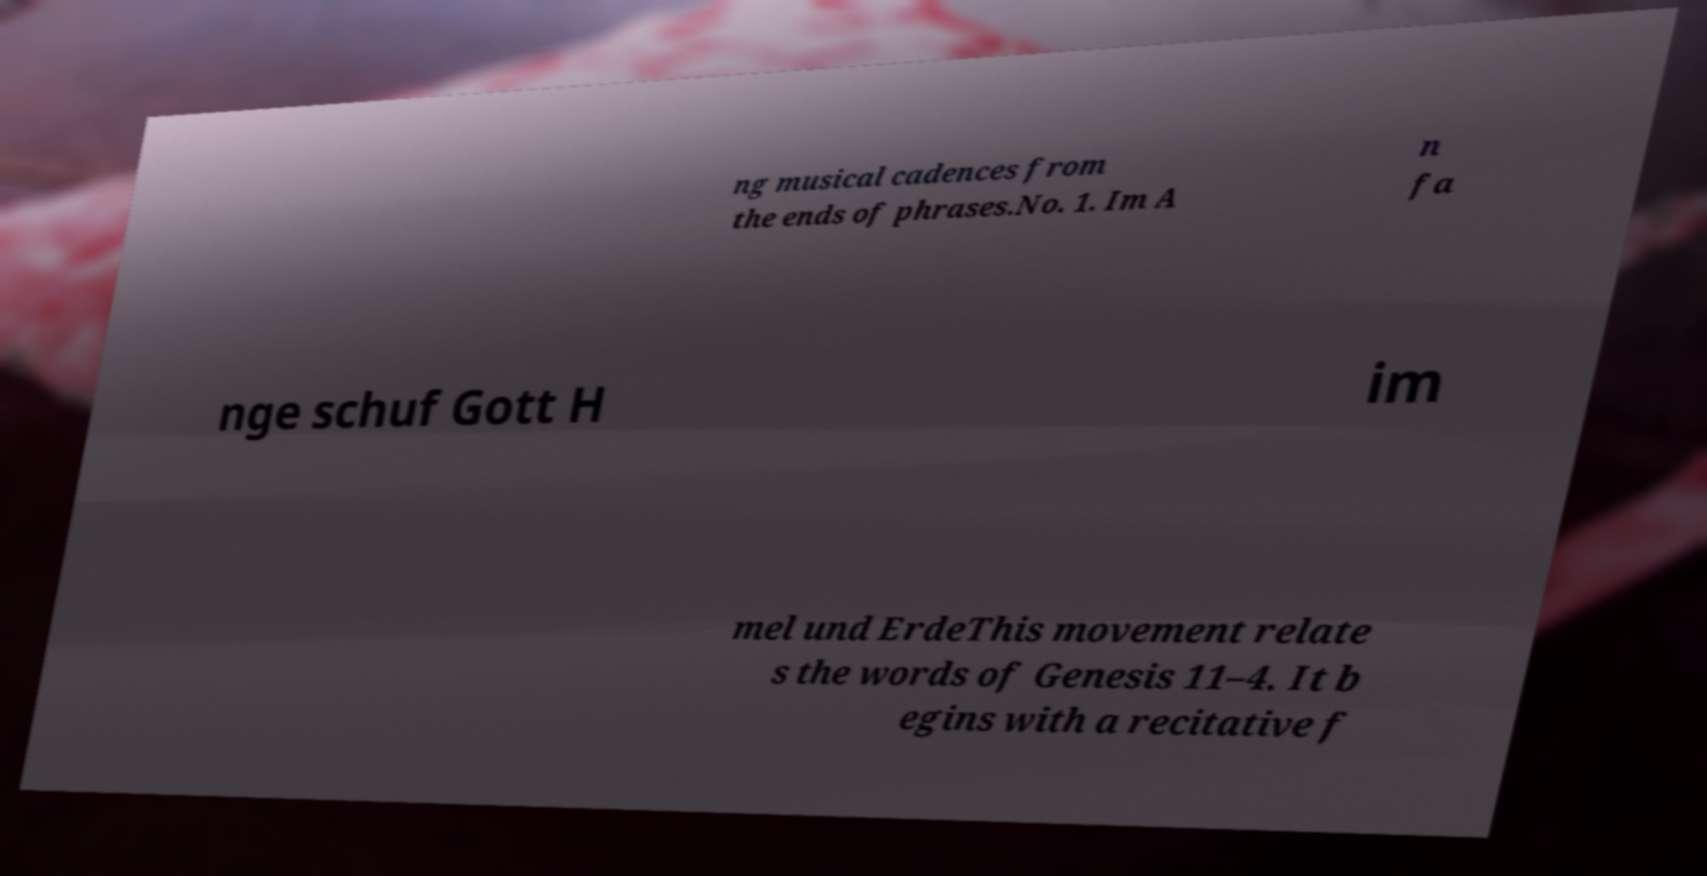Could you extract and type out the text from this image? ng musical cadences from the ends of phrases.No. 1. Im A n fa nge schuf Gott H im mel und ErdeThis movement relate s the words of Genesis 11–4. It b egins with a recitative f 